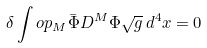<formula> <loc_0><loc_0><loc_500><loc_500>\delta \int o p _ { M } \bar { \Phi } D ^ { M } \Phi \sqrt { g } \, d ^ { 4 } x = 0</formula> 